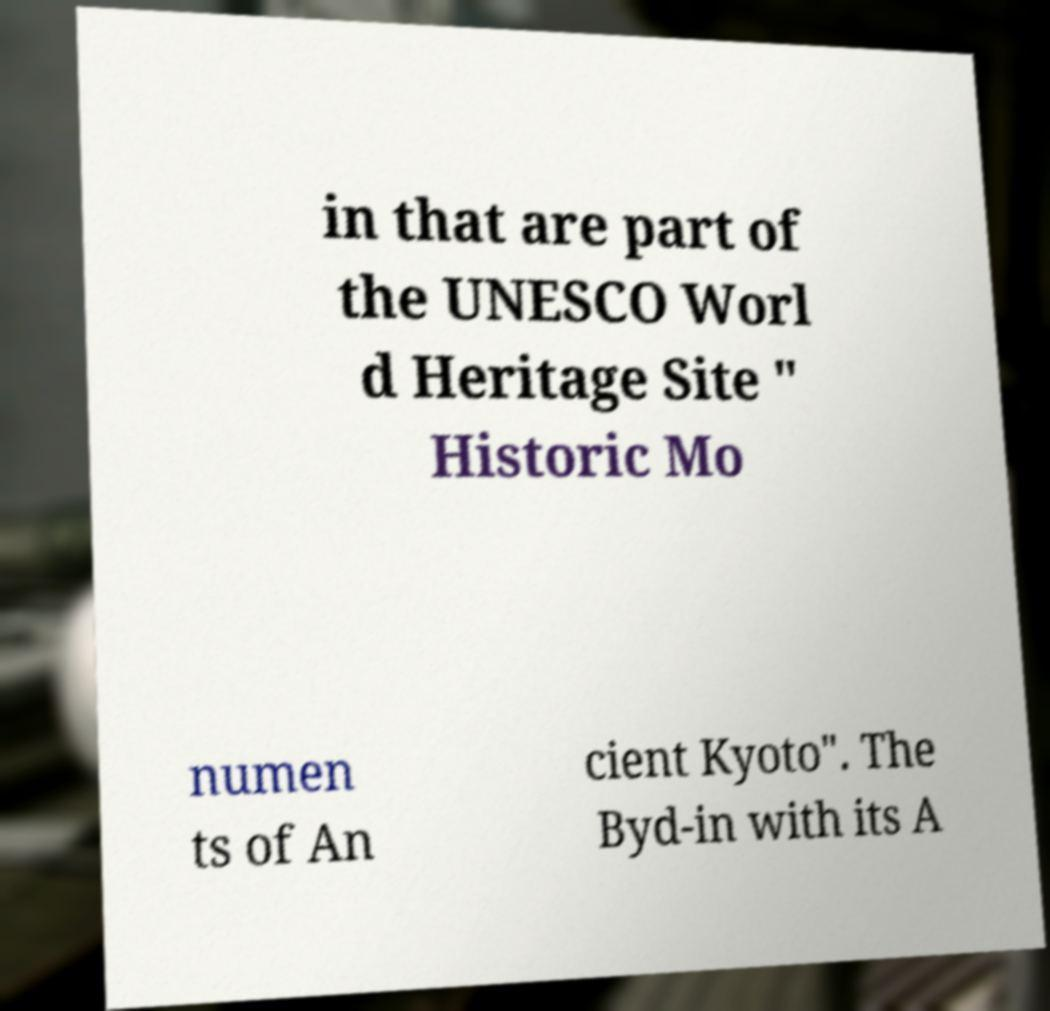Can you read and provide the text displayed in the image?This photo seems to have some interesting text. Can you extract and type it out for me? in that are part of the UNESCO Worl d Heritage Site " Historic Mo numen ts of An cient Kyoto". The Byd-in with its A 